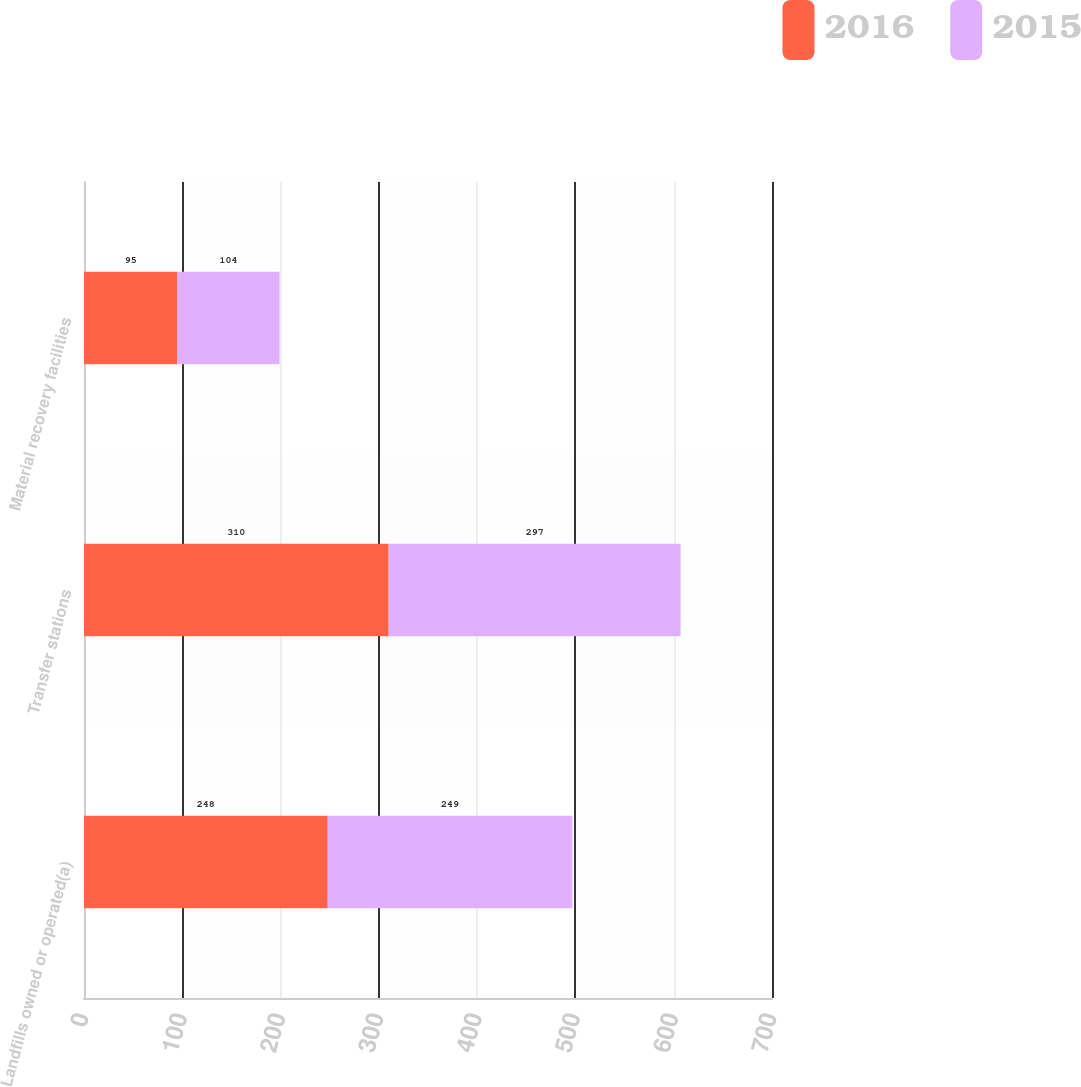<chart> <loc_0><loc_0><loc_500><loc_500><stacked_bar_chart><ecel><fcel>Landfills owned or operated(a)<fcel>Transfer stations<fcel>Material recovery facilities<nl><fcel>2016<fcel>248<fcel>310<fcel>95<nl><fcel>2015<fcel>249<fcel>297<fcel>104<nl></chart> 